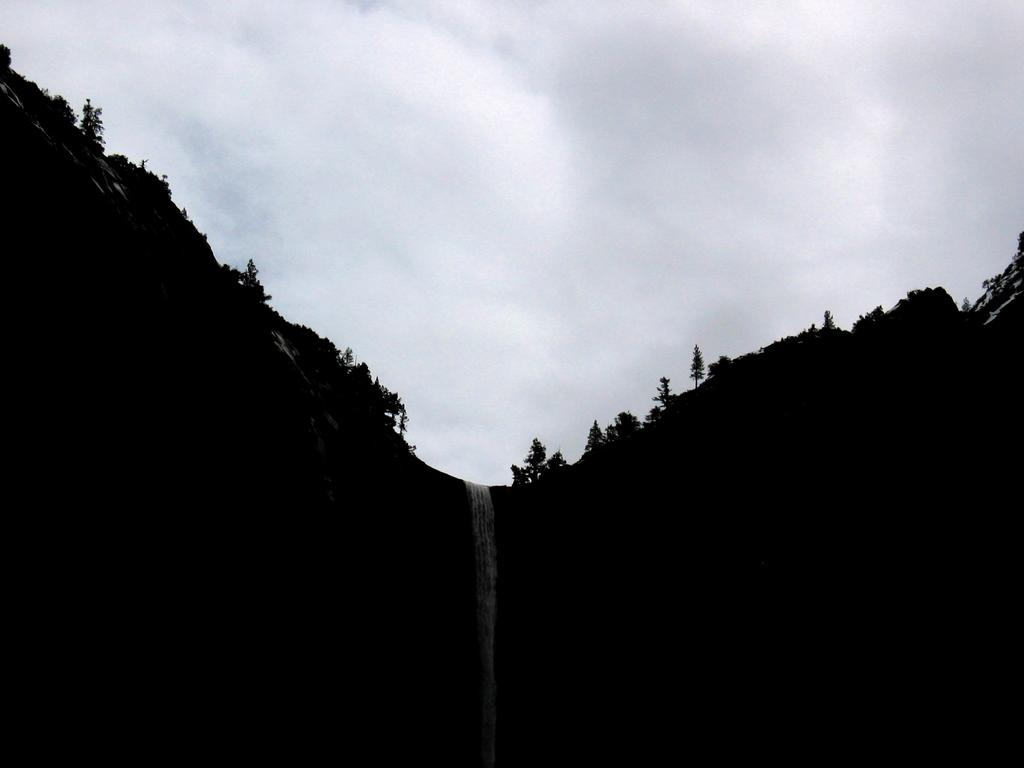What is the main feature in the middle of the image? There is a waterfall in the middle of the image. What type of vegetation can be seen on either side of the image? There are trees on either side of the image. What type of landscape feature can be seen on either side of the image? There are hills on either side of the image. What is visible in the background of the image? The sky is visible in the background of the image. What type of humor can be seen in the image? There is no humor present in the image; it is a natural scene featuring a waterfall, trees, hills, and the sky. 